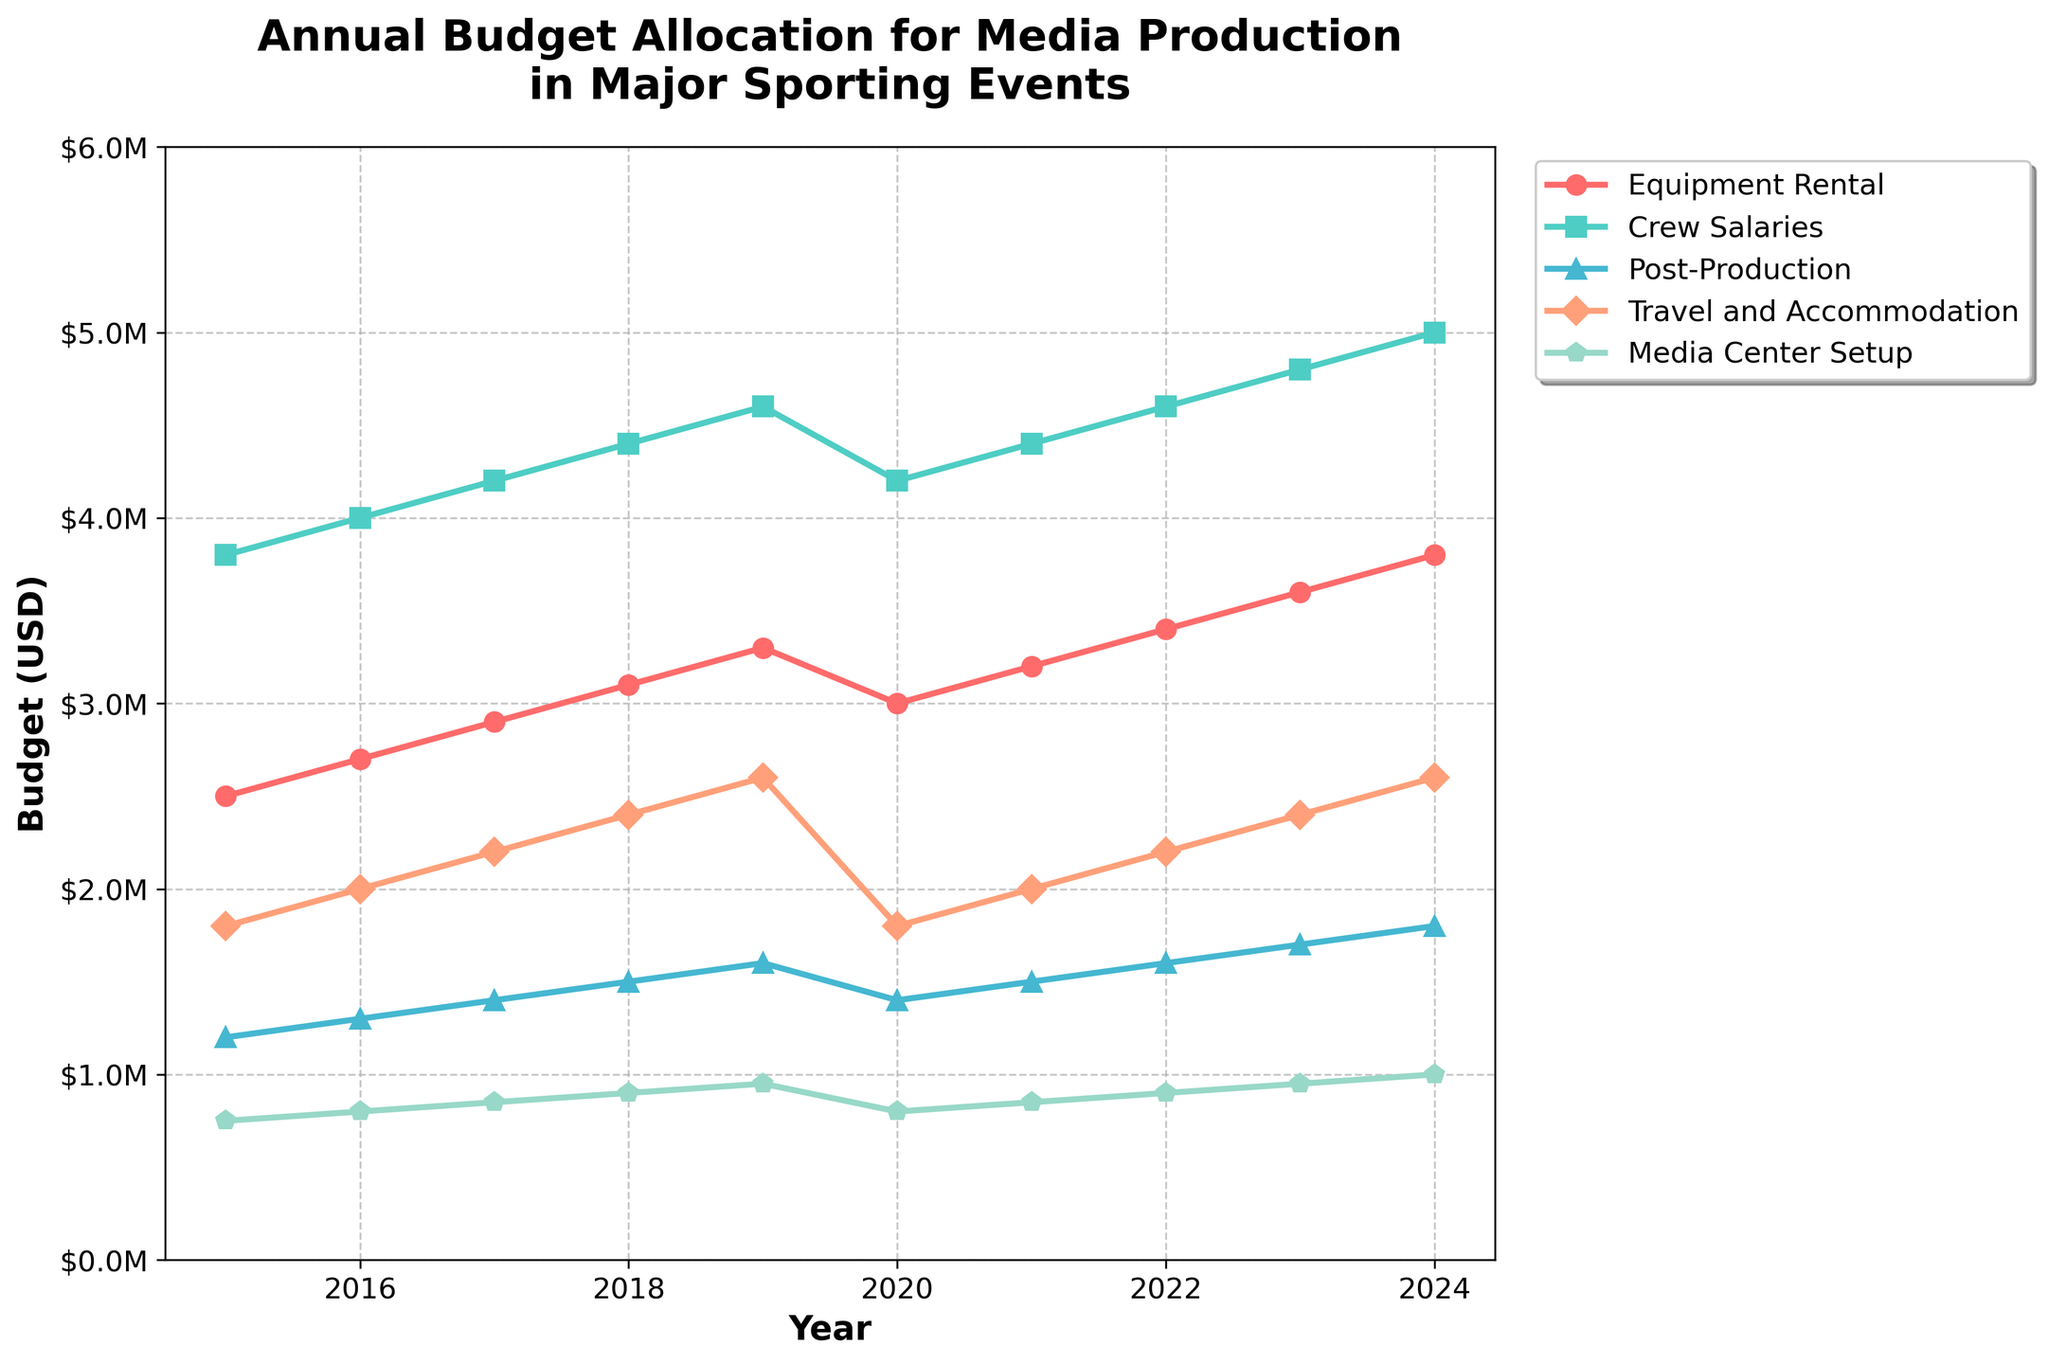What is the overall trend for Crew Salaries from 2015 to 2024? The line representing Crew Salaries shows a steady increase over the years from 2015 to 2024. The line slopes upward continuously, indicating consistent growth.
Answer: Increasing How much did the budget for Equipment Rental increase from 2015 to 2024? In 2015, the budget for Equipment Rental was $2,500,000, and in 2024, it was $3,800,000. The increase is calculated by subtracting the 2015 value from the 2024 value: $3,800,000 - $2,500,000 = $1,300,000.
Answer: $1,300,000 Which expense category saw the highest budget in 2023? By looking at the heights of the plotted lines for each category in the year 2023, Broadcast Rights had the highest budget.
Answer: Broadcast Rights In which year did Post-Production have the lowest budget, and what was the amount? The Post-Production budget was lowest in the year 2015, where it was $1,200,000.
Answer: 2015, $1,200,000 Compare the budgets for Travel and Accommodation in 2017 and 2020. Which year had a higher allocation, and by how much? In 2017, the Travel and Accommodation budget was $2,200,000. In 2020, it was $1,800,000. The difference can be calculated as $2,200,000 - $1,800,000 = $400,000. Thus, 2017 had a higher allocation by $400,000.
Answer: 2017, $400,000 What is the average budget for Media Center Setup from 2017 to 2024? The budgets from 2017 to 2024 are $850,000, $900,000, $950,000, $800,000, $850,000, $900,000, $950,000, and $1,000,000. The average is calculated as the sum of these values divided by the number of years: (850000 + 900000 + 950000 + 800000 + 850000 + 900000 + 950000 + 1000000) / 8 = $912,500.
Answer: $912,500 Which year experienced a decrease in Equipment Rental budget compared to the previous year? Examining the trend lines, the Equipment Rental budget decreased from 2019 to 2020, from $3,300,000 to $3,000,000.
Answer: 2020 How did the budget for Broadcast Rights change from 2018 to 2019, and what is the percentage increase? The budget for Broadcast Rights in 2018 was $19,500,000 and in 2019 was $21,000,000. The increase is $21,000,000 - $19,500,000 = $1,500,000. The percentage increase is ($1,500,000 / $19,500,000) * 100% = 7.69%.
Answer: $1,500,000, 7.69% What is the difference between the highest and lowest Crew Salaries budget observed in the figure? The highest Crew Salaries budget was in 2024 at $5,000,000, and the lowest was in 2015 at $3,800,000. The difference is $5,000,000 - $3,800,000 = $1,200,000.
Answer: $1,200,000 